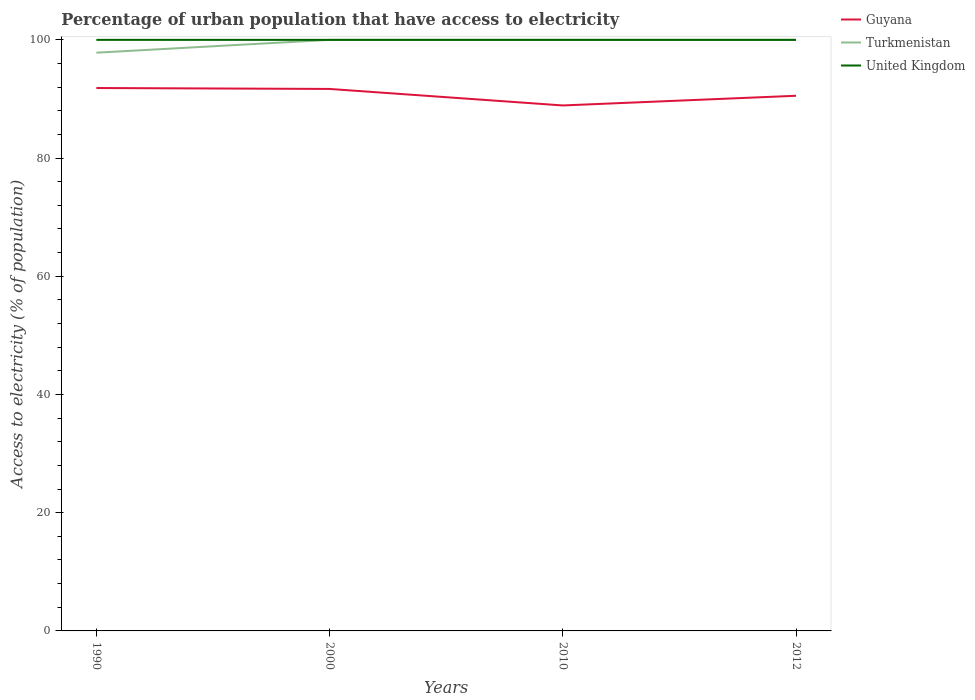How many different coloured lines are there?
Make the answer very short. 3. Across all years, what is the maximum percentage of urban population that have access to electricity in Turkmenistan?
Provide a succinct answer. 97.83. In which year was the percentage of urban population that have access to electricity in Guyana maximum?
Offer a very short reply. 2010. What is the total percentage of urban population that have access to electricity in United Kingdom in the graph?
Ensure brevity in your answer.  0. What is the difference between the highest and the second highest percentage of urban population that have access to electricity in Guyana?
Keep it short and to the point. 2.95. How many lines are there?
Give a very brief answer. 3. How many years are there in the graph?
Give a very brief answer. 4. Are the values on the major ticks of Y-axis written in scientific E-notation?
Your answer should be compact. No. Where does the legend appear in the graph?
Your answer should be compact. Top right. What is the title of the graph?
Offer a very short reply. Percentage of urban population that have access to electricity. Does "Seychelles" appear as one of the legend labels in the graph?
Keep it short and to the point. No. What is the label or title of the X-axis?
Your answer should be compact. Years. What is the label or title of the Y-axis?
Provide a short and direct response. Access to electricity (% of population). What is the Access to electricity (% of population) in Guyana in 1990?
Offer a terse response. 91.85. What is the Access to electricity (% of population) of Turkmenistan in 1990?
Provide a succinct answer. 97.83. What is the Access to electricity (% of population) of United Kingdom in 1990?
Provide a short and direct response. 100. What is the Access to electricity (% of population) of Guyana in 2000?
Offer a very short reply. 91.69. What is the Access to electricity (% of population) of Guyana in 2010?
Keep it short and to the point. 88.9. What is the Access to electricity (% of population) of Guyana in 2012?
Keep it short and to the point. 90.54. Across all years, what is the maximum Access to electricity (% of population) of Guyana?
Provide a succinct answer. 91.85. Across all years, what is the minimum Access to electricity (% of population) in Guyana?
Ensure brevity in your answer.  88.9. Across all years, what is the minimum Access to electricity (% of population) in Turkmenistan?
Offer a very short reply. 97.83. What is the total Access to electricity (% of population) in Guyana in the graph?
Your answer should be very brief. 362.99. What is the total Access to electricity (% of population) of Turkmenistan in the graph?
Keep it short and to the point. 397.83. What is the difference between the Access to electricity (% of population) in Guyana in 1990 and that in 2000?
Ensure brevity in your answer.  0.16. What is the difference between the Access to electricity (% of population) in Turkmenistan in 1990 and that in 2000?
Your answer should be very brief. -2.17. What is the difference between the Access to electricity (% of population) in United Kingdom in 1990 and that in 2000?
Provide a succinct answer. 0. What is the difference between the Access to electricity (% of population) of Guyana in 1990 and that in 2010?
Ensure brevity in your answer.  2.95. What is the difference between the Access to electricity (% of population) of Turkmenistan in 1990 and that in 2010?
Your answer should be very brief. -2.17. What is the difference between the Access to electricity (% of population) of Guyana in 1990 and that in 2012?
Offer a very short reply. 1.31. What is the difference between the Access to electricity (% of population) of Turkmenistan in 1990 and that in 2012?
Ensure brevity in your answer.  -2.17. What is the difference between the Access to electricity (% of population) of United Kingdom in 1990 and that in 2012?
Keep it short and to the point. 0. What is the difference between the Access to electricity (% of population) of Guyana in 2000 and that in 2010?
Keep it short and to the point. 2.79. What is the difference between the Access to electricity (% of population) of United Kingdom in 2000 and that in 2010?
Your answer should be very brief. 0. What is the difference between the Access to electricity (% of population) of Guyana in 2000 and that in 2012?
Keep it short and to the point. 1.15. What is the difference between the Access to electricity (% of population) in Turkmenistan in 2000 and that in 2012?
Your answer should be compact. 0. What is the difference between the Access to electricity (% of population) in Guyana in 2010 and that in 2012?
Offer a very short reply. -1.64. What is the difference between the Access to electricity (% of population) in Turkmenistan in 2010 and that in 2012?
Give a very brief answer. 0. What is the difference between the Access to electricity (% of population) in Guyana in 1990 and the Access to electricity (% of population) in Turkmenistan in 2000?
Provide a short and direct response. -8.15. What is the difference between the Access to electricity (% of population) of Guyana in 1990 and the Access to electricity (% of population) of United Kingdom in 2000?
Keep it short and to the point. -8.15. What is the difference between the Access to electricity (% of population) in Turkmenistan in 1990 and the Access to electricity (% of population) in United Kingdom in 2000?
Offer a terse response. -2.17. What is the difference between the Access to electricity (% of population) in Guyana in 1990 and the Access to electricity (% of population) in Turkmenistan in 2010?
Make the answer very short. -8.15. What is the difference between the Access to electricity (% of population) of Guyana in 1990 and the Access to electricity (% of population) of United Kingdom in 2010?
Provide a succinct answer. -8.15. What is the difference between the Access to electricity (% of population) in Turkmenistan in 1990 and the Access to electricity (% of population) in United Kingdom in 2010?
Provide a short and direct response. -2.17. What is the difference between the Access to electricity (% of population) in Guyana in 1990 and the Access to electricity (% of population) in Turkmenistan in 2012?
Your answer should be very brief. -8.15. What is the difference between the Access to electricity (% of population) in Guyana in 1990 and the Access to electricity (% of population) in United Kingdom in 2012?
Keep it short and to the point. -8.15. What is the difference between the Access to electricity (% of population) in Turkmenistan in 1990 and the Access to electricity (% of population) in United Kingdom in 2012?
Give a very brief answer. -2.17. What is the difference between the Access to electricity (% of population) in Guyana in 2000 and the Access to electricity (% of population) in Turkmenistan in 2010?
Provide a succinct answer. -8.31. What is the difference between the Access to electricity (% of population) in Guyana in 2000 and the Access to electricity (% of population) in United Kingdom in 2010?
Offer a very short reply. -8.31. What is the difference between the Access to electricity (% of population) in Turkmenistan in 2000 and the Access to electricity (% of population) in United Kingdom in 2010?
Provide a short and direct response. 0. What is the difference between the Access to electricity (% of population) of Guyana in 2000 and the Access to electricity (% of population) of Turkmenistan in 2012?
Offer a very short reply. -8.31. What is the difference between the Access to electricity (% of population) in Guyana in 2000 and the Access to electricity (% of population) in United Kingdom in 2012?
Provide a succinct answer. -8.31. What is the difference between the Access to electricity (% of population) in Guyana in 2010 and the Access to electricity (% of population) in Turkmenistan in 2012?
Your answer should be very brief. -11.1. What is the difference between the Access to electricity (% of population) in Guyana in 2010 and the Access to electricity (% of population) in United Kingdom in 2012?
Provide a succinct answer. -11.1. What is the average Access to electricity (% of population) in Guyana per year?
Your response must be concise. 90.75. What is the average Access to electricity (% of population) of Turkmenistan per year?
Make the answer very short. 99.46. What is the average Access to electricity (% of population) in United Kingdom per year?
Provide a short and direct response. 100. In the year 1990, what is the difference between the Access to electricity (% of population) in Guyana and Access to electricity (% of population) in Turkmenistan?
Your response must be concise. -5.98. In the year 1990, what is the difference between the Access to electricity (% of population) in Guyana and Access to electricity (% of population) in United Kingdom?
Ensure brevity in your answer.  -8.15. In the year 1990, what is the difference between the Access to electricity (% of population) of Turkmenistan and Access to electricity (% of population) of United Kingdom?
Offer a very short reply. -2.17. In the year 2000, what is the difference between the Access to electricity (% of population) of Guyana and Access to electricity (% of population) of Turkmenistan?
Give a very brief answer. -8.31. In the year 2000, what is the difference between the Access to electricity (% of population) in Guyana and Access to electricity (% of population) in United Kingdom?
Your answer should be compact. -8.31. In the year 2000, what is the difference between the Access to electricity (% of population) of Turkmenistan and Access to electricity (% of population) of United Kingdom?
Provide a succinct answer. 0. In the year 2010, what is the difference between the Access to electricity (% of population) in Guyana and Access to electricity (% of population) in Turkmenistan?
Your response must be concise. -11.1. In the year 2010, what is the difference between the Access to electricity (% of population) of Guyana and Access to electricity (% of population) of United Kingdom?
Offer a terse response. -11.1. In the year 2012, what is the difference between the Access to electricity (% of population) of Guyana and Access to electricity (% of population) of Turkmenistan?
Make the answer very short. -9.46. In the year 2012, what is the difference between the Access to electricity (% of population) of Guyana and Access to electricity (% of population) of United Kingdom?
Your answer should be compact. -9.46. What is the ratio of the Access to electricity (% of population) in Guyana in 1990 to that in 2000?
Offer a very short reply. 1. What is the ratio of the Access to electricity (% of population) of Turkmenistan in 1990 to that in 2000?
Offer a terse response. 0.98. What is the ratio of the Access to electricity (% of population) of United Kingdom in 1990 to that in 2000?
Give a very brief answer. 1. What is the ratio of the Access to electricity (% of population) in Guyana in 1990 to that in 2010?
Give a very brief answer. 1.03. What is the ratio of the Access to electricity (% of population) in Turkmenistan in 1990 to that in 2010?
Provide a short and direct response. 0.98. What is the ratio of the Access to electricity (% of population) of United Kingdom in 1990 to that in 2010?
Your answer should be compact. 1. What is the ratio of the Access to electricity (% of population) of Guyana in 1990 to that in 2012?
Offer a very short reply. 1.01. What is the ratio of the Access to electricity (% of population) of Turkmenistan in 1990 to that in 2012?
Keep it short and to the point. 0.98. What is the ratio of the Access to electricity (% of population) in Guyana in 2000 to that in 2010?
Provide a short and direct response. 1.03. What is the ratio of the Access to electricity (% of population) in United Kingdom in 2000 to that in 2010?
Offer a very short reply. 1. What is the ratio of the Access to electricity (% of population) of Guyana in 2000 to that in 2012?
Your answer should be very brief. 1.01. What is the ratio of the Access to electricity (% of population) in Turkmenistan in 2000 to that in 2012?
Ensure brevity in your answer.  1. What is the ratio of the Access to electricity (% of population) of United Kingdom in 2000 to that in 2012?
Make the answer very short. 1. What is the ratio of the Access to electricity (% of population) of Guyana in 2010 to that in 2012?
Your answer should be very brief. 0.98. What is the ratio of the Access to electricity (% of population) in United Kingdom in 2010 to that in 2012?
Keep it short and to the point. 1. What is the difference between the highest and the second highest Access to electricity (% of population) in Guyana?
Your answer should be very brief. 0.16. What is the difference between the highest and the second highest Access to electricity (% of population) of Turkmenistan?
Keep it short and to the point. 0. What is the difference between the highest and the second highest Access to electricity (% of population) in United Kingdom?
Make the answer very short. 0. What is the difference between the highest and the lowest Access to electricity (% of population) in Guyana?
Offer a very short reply. 2.95. What is the difference between the highest and the lowest Access to electricity (% of population) of Turkmenistan?
Make the answer very short. 2.17. 